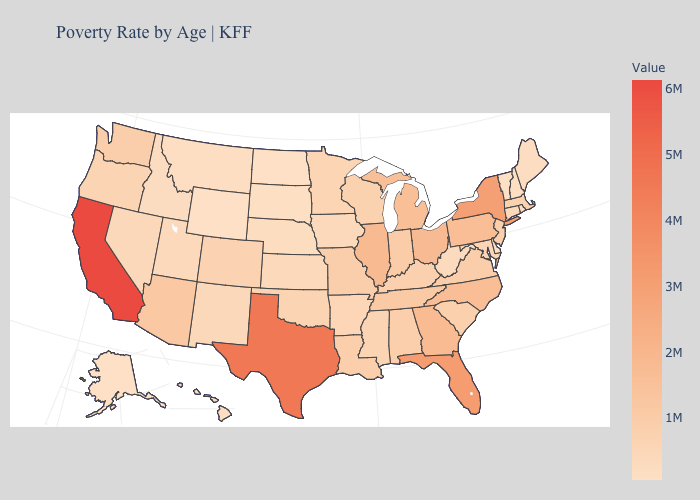Among the states that border Connecticut , which have the highest value?
Write a very short answer. New York. Does the map have missing data?
Quick response, please. No. Does North Carolina have the highest value in the South?
Answer briefly. No. 